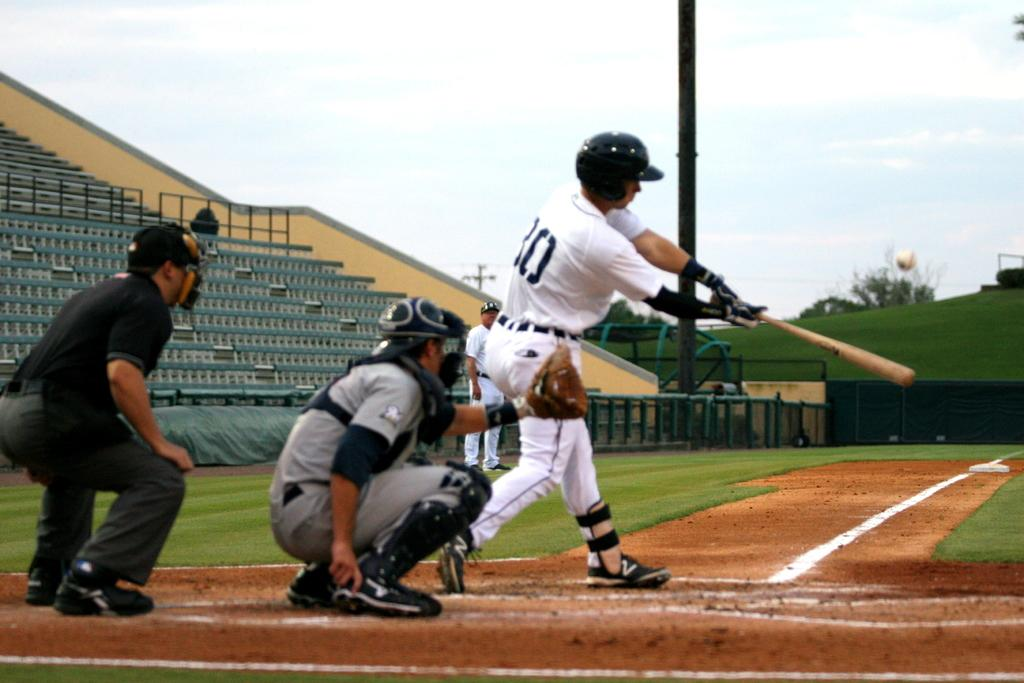<image>
Write a terse but informative summary of the picture. Player 30 is up at bat with the catcher and an umpire behind him. 